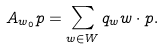Convert formula to latex. <formula><loc_0><loc_0><loc_500><loc_500>A _ { w _ { 0 } } p = \sum _ { w \in W } q _ { w } w \cdot p .</formula> 